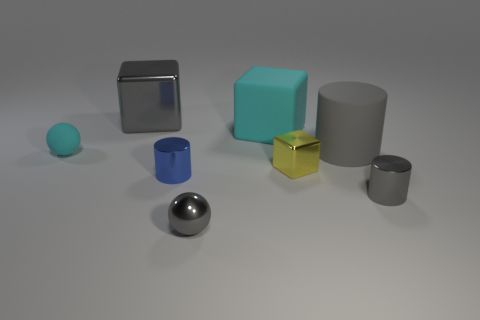Are there any other things that are made of the same material as the blue object?
Make the answer very short. Yes. The big gray thing that is the same material as the yellow cube is what shape?
Make the answer very short. Cube. Are there fewer large shiny cubes in front of the small block than small gray shiny cylinders behind the large matte cylinder?
Offer a very short reply. No. What number of small things are either red objects or blue shiny objects?
Ensure brevity in your answer.  1. Do the gray shiny object on the right side of the yellow metallic thing and the matte object that is in front of the gray matte cylinder have the same shape?
Offer a very short reply. No. How big is the rubber thing that is left of the gray metallic block on the left side of the small metal cylinder that is to the left of the small gray sphere?
Provide a succinct answer. Small. What size is the gray shiny thing that is behind the yellow metallic block?
Provide a short and direct response. Large. There is a ball that is in front of the tiny cyan rubber object; what is it made of?
Your response must be concise. Metal. How many red things are cylinders or big metallic cubes?
Your answer should be compact. 0. Do the large cylinder and the big gray thing that is behind the big gray cylinder have the same material?
Your response must be concise. No. 